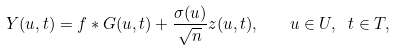<formula> <loc_0><loc_0><loc_500><loc_500>Y ( u , t ) = f * G ( u , t ) + \frac { \sigma ( u ) } { \sqrt { n } } z ( u , t ) , \quad u \in U , \ t \in T ,</formula> 